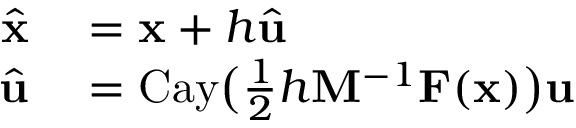<formula> <loc_0><loc_0><loc_500><loc_500>\begin{array} { r l } { \widehat { x } } & = x + h \widehat { u } } \\ { \widehat { u } } & = C a y \left ( \frac { 1 } { 2 } h M ^ { - 1 } F ( x ) \right ) u } \end{array}</formula> 